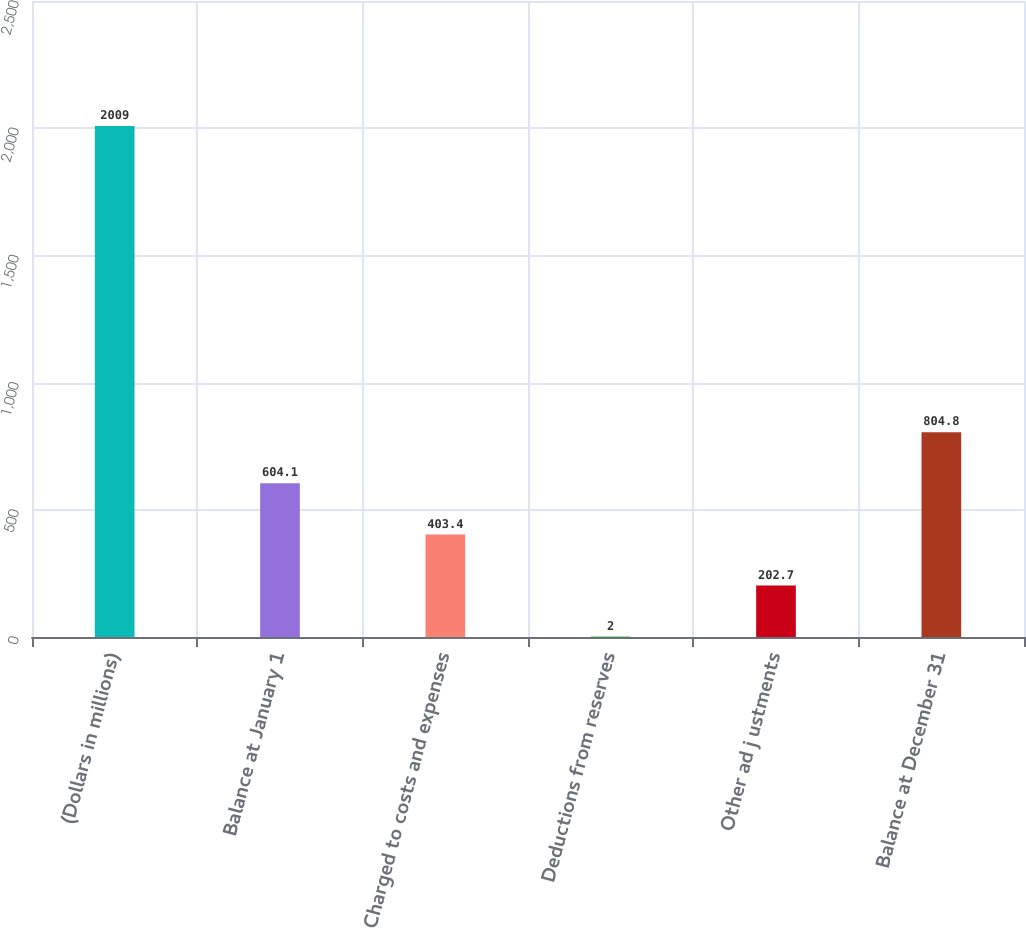Convert chart. <chart><loc_0><loc_0><loc_500><loc_500><bar_chart><fcel>(Dollars in millions)<fcel>Balance at January 1<fcel>Charged to costs and expenses<fcel>Deductions from reserves<fcel>Other ad j ustments<fcel>Balance at December 31<nl><fcel>2009<fcel>604.1<fcel>403.4<fcel>2<fcel>202.7<fcel>804.8<nl></chart> 